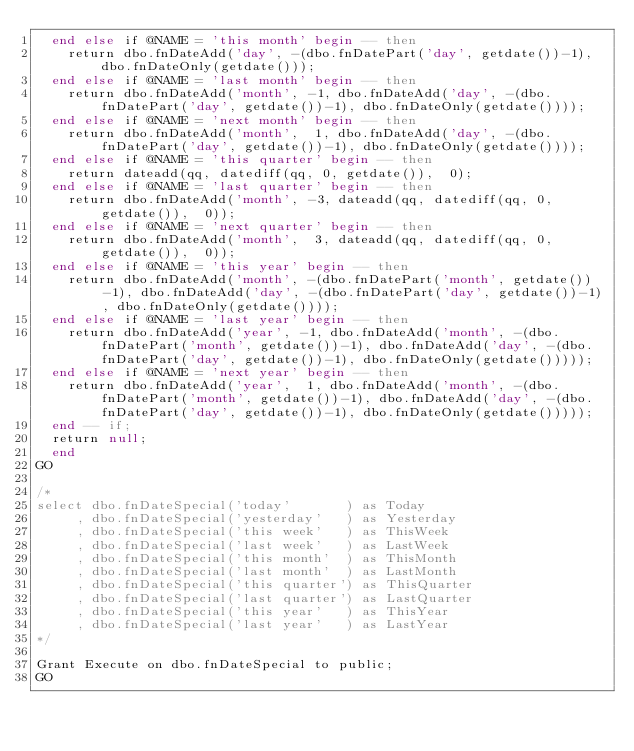Convert code to text. <code><loc_0><loc_0><loc_500><loc_500><_SQL_>	end else if @NAME = 'this month' begin -- then
		return dbo.fnDateAdd('day', -(dbo.fnDatePart('day', getdate())-1), dbo.fnDateOnly(getdate()));
	end else if @NAME = 'last month' begin -- then
		return dbo.fnDateAdd('month', -1, dbo.fnDateAdd('day', -(dbo.fnDatePart('day', getdate())-1), dbo.fnDateOnly(getdate())));
	end else if @NAME = 'next month' begin -- then
		return dbo.fnDateAdd('month',  1, dbo.fnDateAdd('day', -(dbo.fnDatePart('day', getdate())-1), dbo.fnDateOnly(getdate())));
	end else if @NAME = 'this quarter' begin -- then
		return dateadd(qq, datediff(qq, 0, getdate()),  0);
	end else if @NAME = 'last quarter' begin -- then
		return dbo.fnDateAdd('month', -3, dateadd(qq, datediff(qq, 0, getdate()),  0));
	end else if @NAME = 'next quarter' begin -- then
		return dbo.fnDateAdd('month',  3, dateadd(qq, datediff(qq, 0, getdate()),  0));
	end else if @NAME = 'this year' begin -- then
		return dbo.fnDateAdd('month', -(dbo.fnDatePart('month', getdate())-1), dbo.fnDateAdd('day', -(dbo.fnDatePart('day', getdate())-1), dbo.fnDateOnly(getdate())));
	end else if @NAME = 'last year' begin -- then
		return dbo.fnDateAdd('year', -1, dbo.fnDateAdd('month', -(dbo.fnDatePart('month', getdate())-1), dbo.fnDateAdd('day', -(dbo.fnDatePart('day', getdate())-1), dbo.fnDateOnly(getdate()))));
	end else if @NAME = 'next year' begin -- then
		return dbo.fnDateAdd('year',  1, dbo.fnDateAdd('month', -(dbo.fnDatePart('month', getdate())-1), dbo.fnDateAdd('day', -(dbo.fnDatePart('day', getdate())-1), dbo.fnDateOnly(getdate()))));
	end -- if;
	return null;
  end
GO

/*
select dbo.fnDateSpecial('today'       ) as Today
     , dbo.fnDateSpecial('yesterday'   ) as Yesterday
     , dbo.fnDateSpecial('this week'   ) as ThisWeek
     , dbo.fnDateSpecial('last week'   ) as LastWeek
     , dbo.fnDateSpecial('this month'  ) as ThisMonth
     , dbo.fnDateSpecial('last month'  ) as LastMonth
     , dbo.fnDateSpecial('this quarter') as ThisQuarter
     , dbo.fnDateSpecial('last quarter') as LastQuarter
     , dbo.fnDateSpecial('this year'   ) as ThisYear
     , dbo.fnDateSpecial('last year'   ) as LastYear
*/

Grant Execute on dbo.fnDateSpecial to public;
GO

</code> 